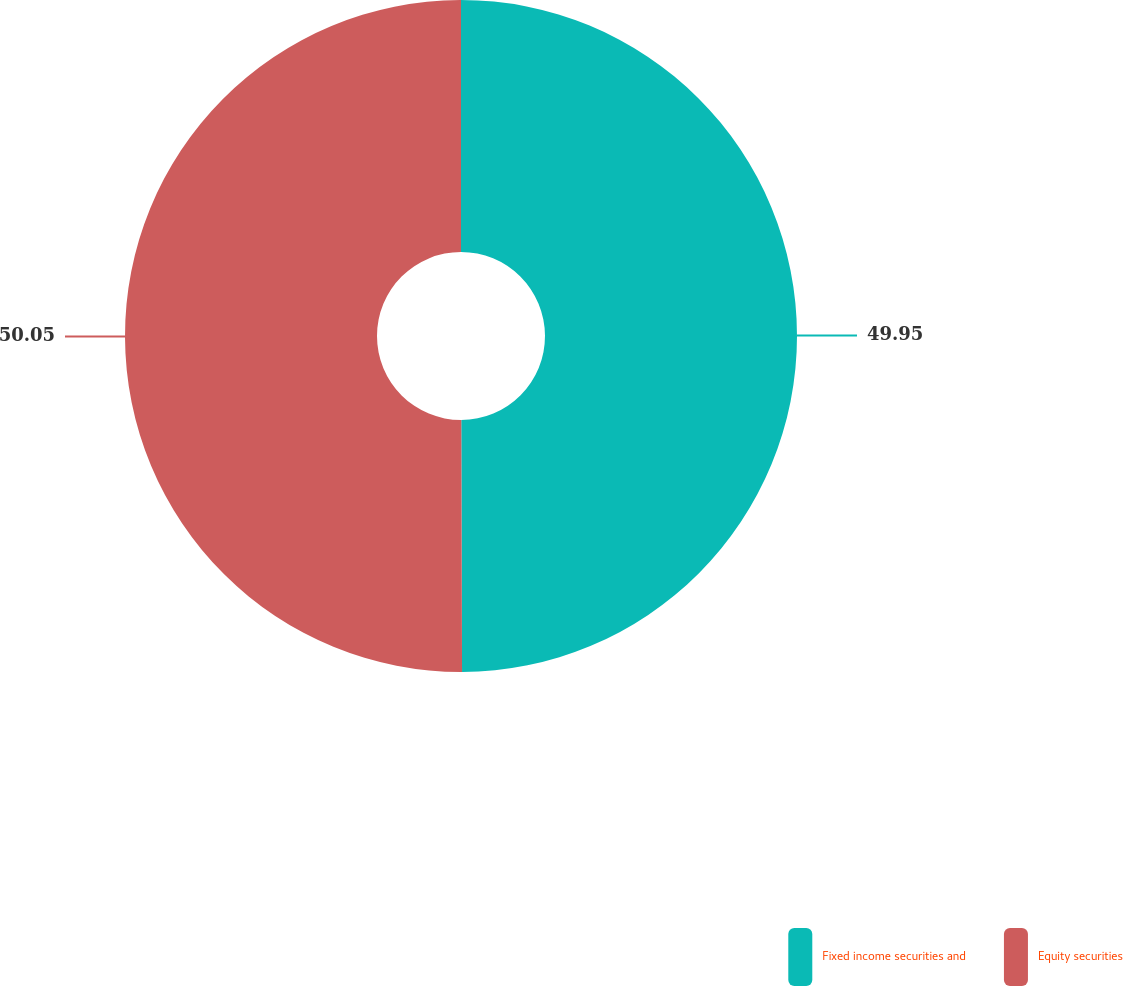Convert chart to OTSL. <chart><loc_0><loc_0><loc_500><loc_500><pie_chart><fcel>Fixed income securities and<fcel>Equity securities<nl><fcel>49.95%<fcel>50.05%<nl></chart> 